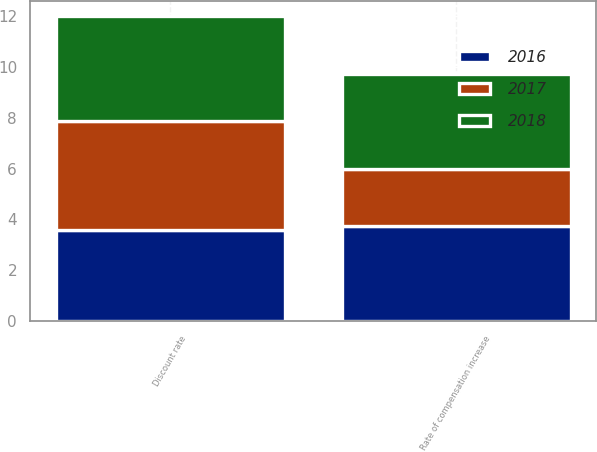<chart> <loc_0><loc_0><loc_500><loc_500><stacked_bar_chart><ecel><fcel>Discount rate<fcel>Rate of compensation increase<nl><fcel>2017<fcel>4.3<fcel>2.25<nl><fcel>2016<fcel>3.6<fcel>3.75<nl><fcel>2018<fcel>4.1<fcel>3.75<nl></chart> 